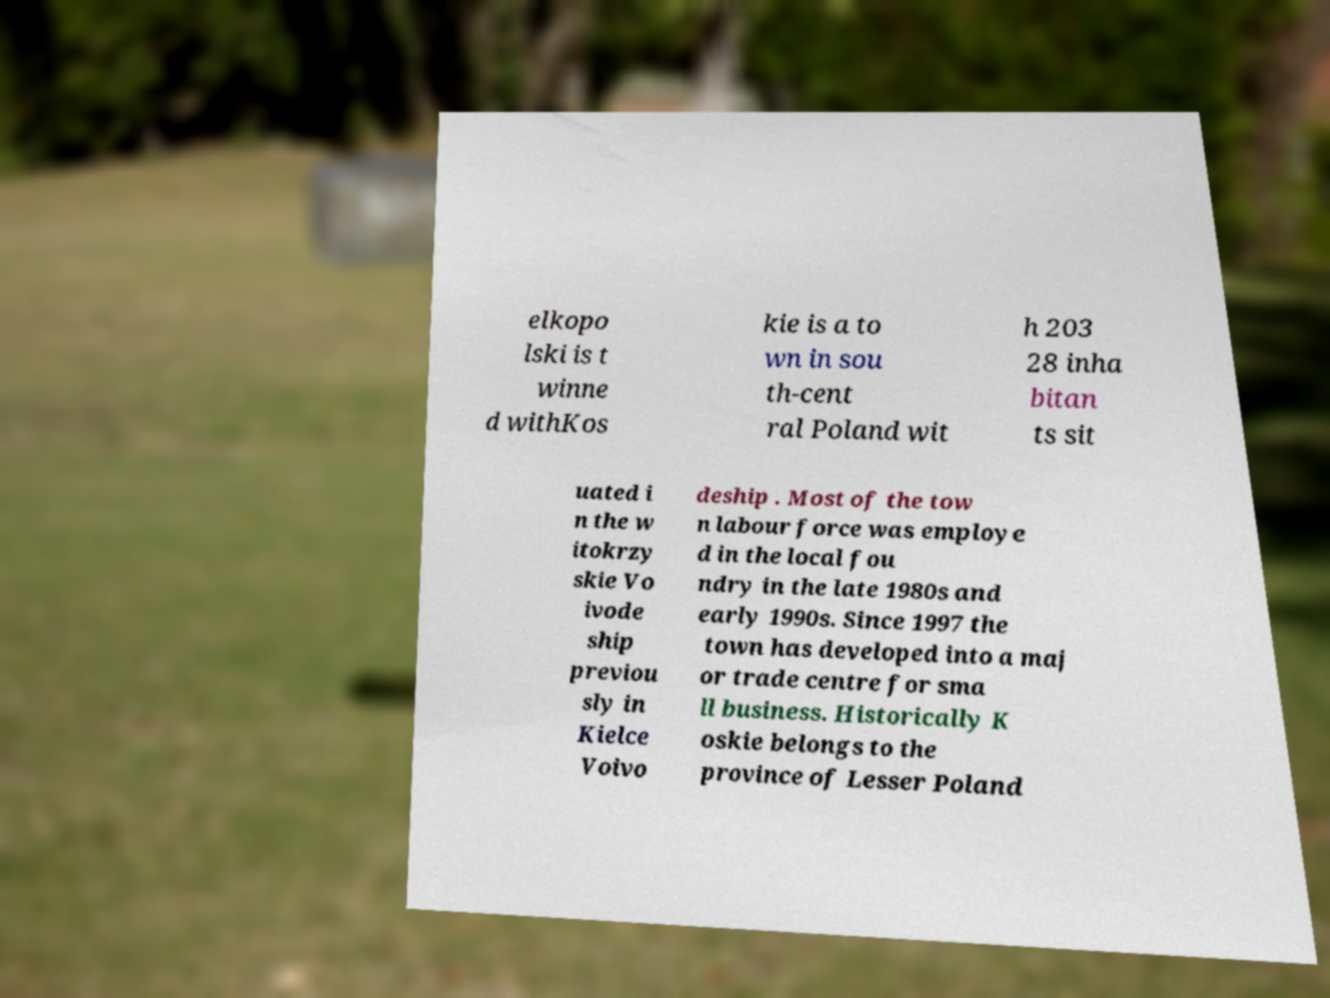Please read and relay the text visible in this image. What does it say? elkopo lski is t winne d withKos kie is a to wn in sou th-cent ral Poland wit h 203 28 inha bitan ts sit uated i n the w itokrzy skie Vo ivode ship previou sly in Kielce Voivo deship . Most of the tow n labour force was employe d in the local fou ndry in the late 1980s and early 1990s. Since 1997 the town has developed into a maj or trade centre for sma ll business. Historically K oskie belongs to the province of Lesser Poland 